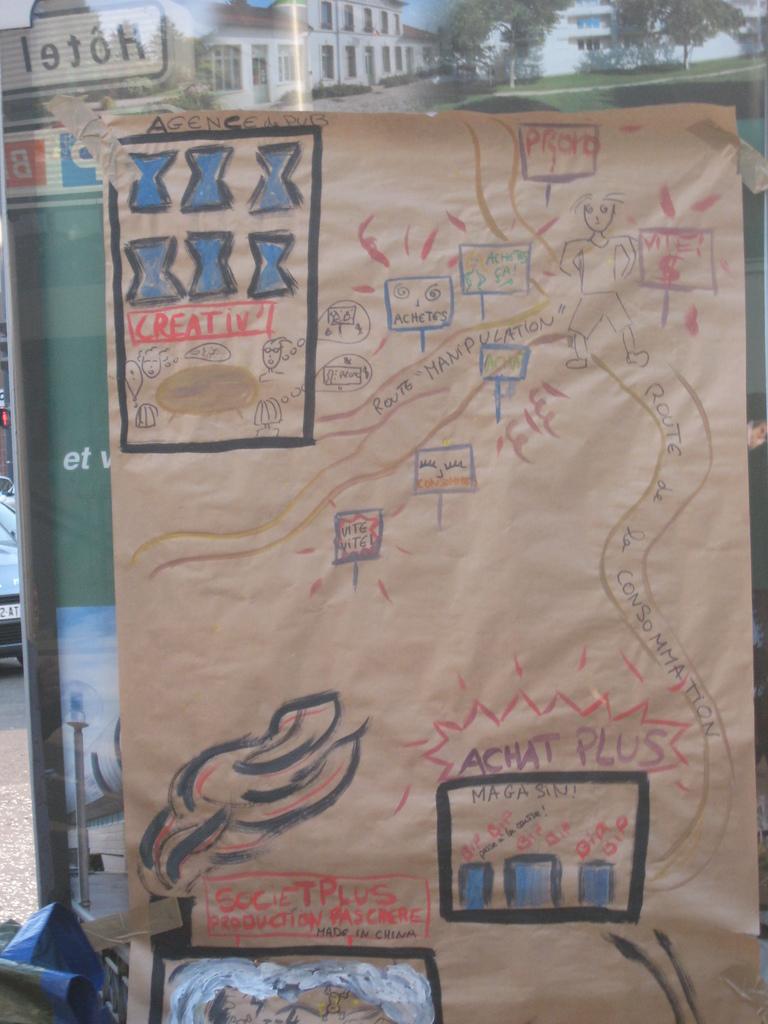What is one of the words on the piece of paper?
Your response must be concise. Plus. 